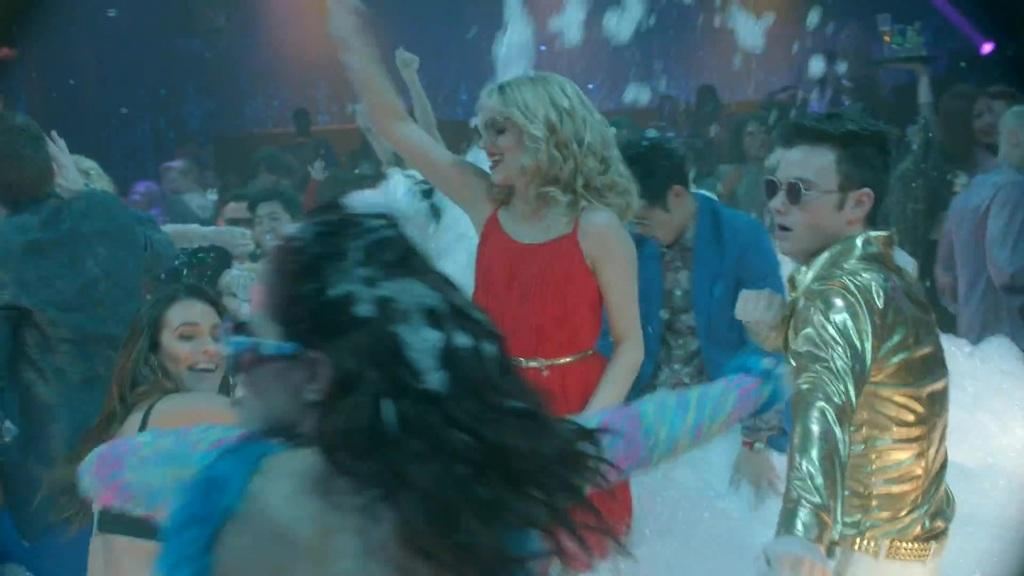What are the people in the image doing? The people in the image are dancing. How many people are in the group? The number of people in the group is not specified, but there is a group of people present. What can be seen in the background of the image? There are objects in the background of the image. Where is the baby sitting in the boat in the image? There is no baby or boat present in the image; the people are dancing and there are objects in the background. 